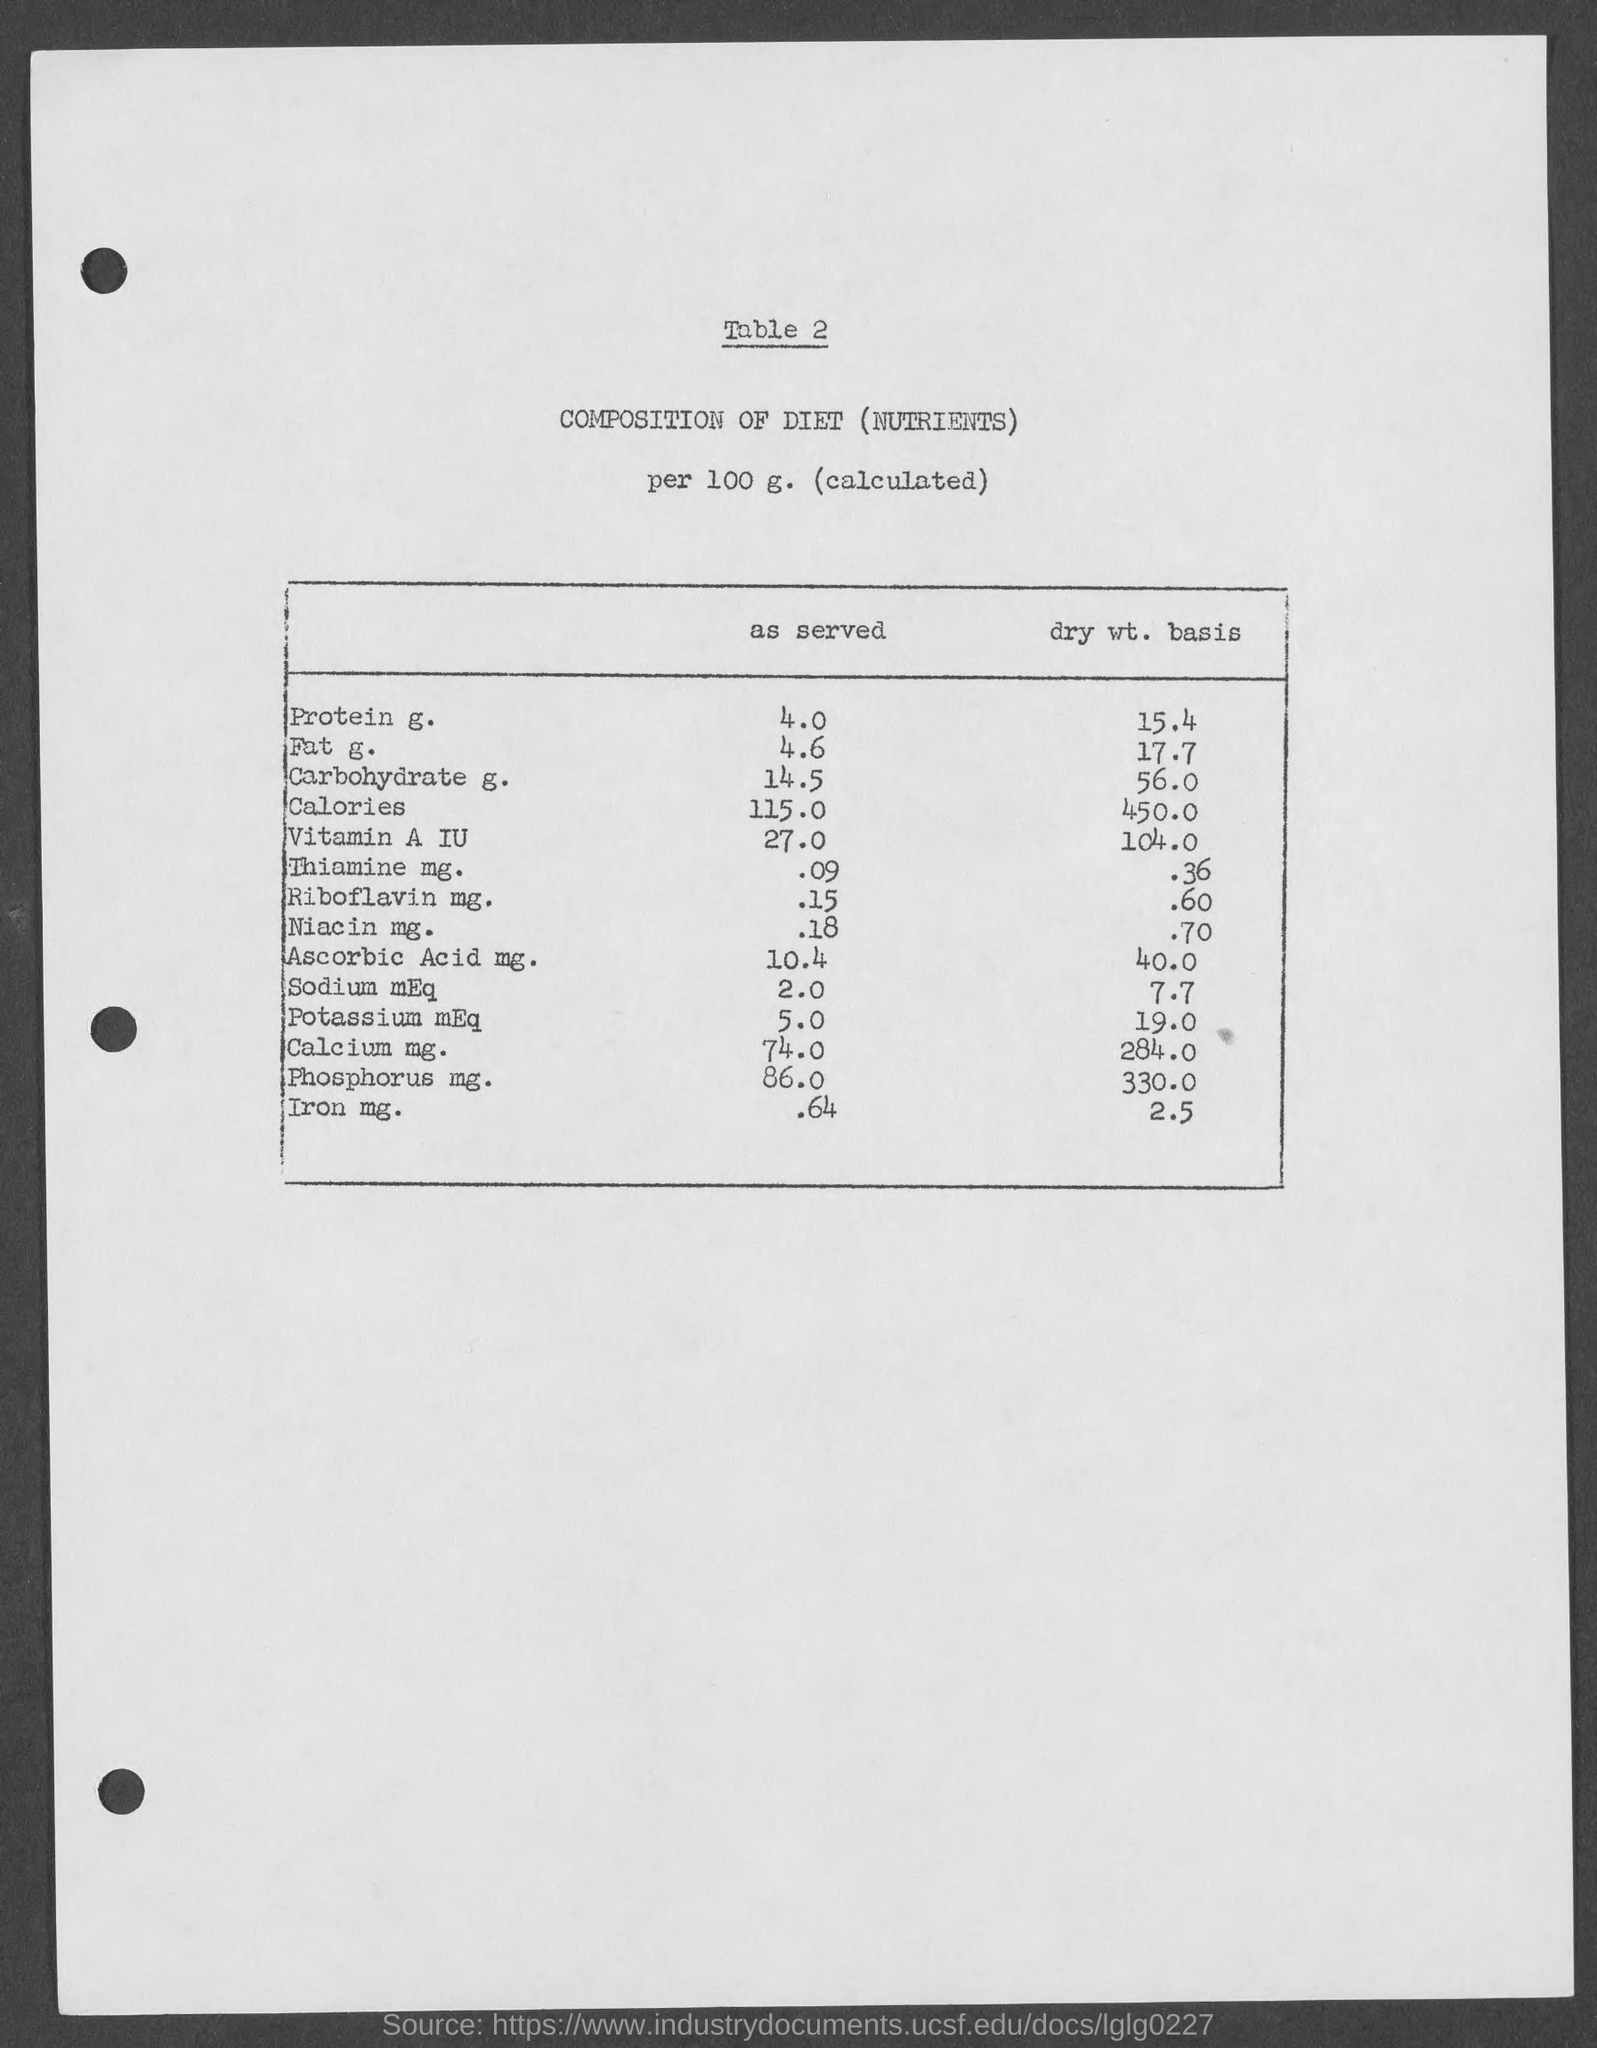What is the amount of protein g. as served in the given table ?
Your answer should be very brief. 4.0. What is the amount of fat g. as served as shown in the given page ?
Your answer should be very brief. 4.6. What is the amount of dry wt. basis of protein g. as mentioned in the given table ?
Your response must be concise. 15.4. What is the amount of dry wt. basis of fat g. as mentioned in the given table ?
Keep it short and to the point. 17.7. What is the amount of carbohydrate g. as served as shown in the given page ?
Your answer should be very brief. 14.5. What is the amount of calories  as served as shown in the given page ?
Make the answer very short. 115.0. What is the amount of dry wt. basis of carbohydrate  g. as mentioned in the given table ?
Make the answer very short. 56.0. What is the amount of dry wt. basis of calories as mentioned in the given table ?
Give a very brief answer. 450.0. What is the amount of dry wt. basis of vitamin a iu  as mentioned in the given table ?
Your response must be concise. 104.0. 